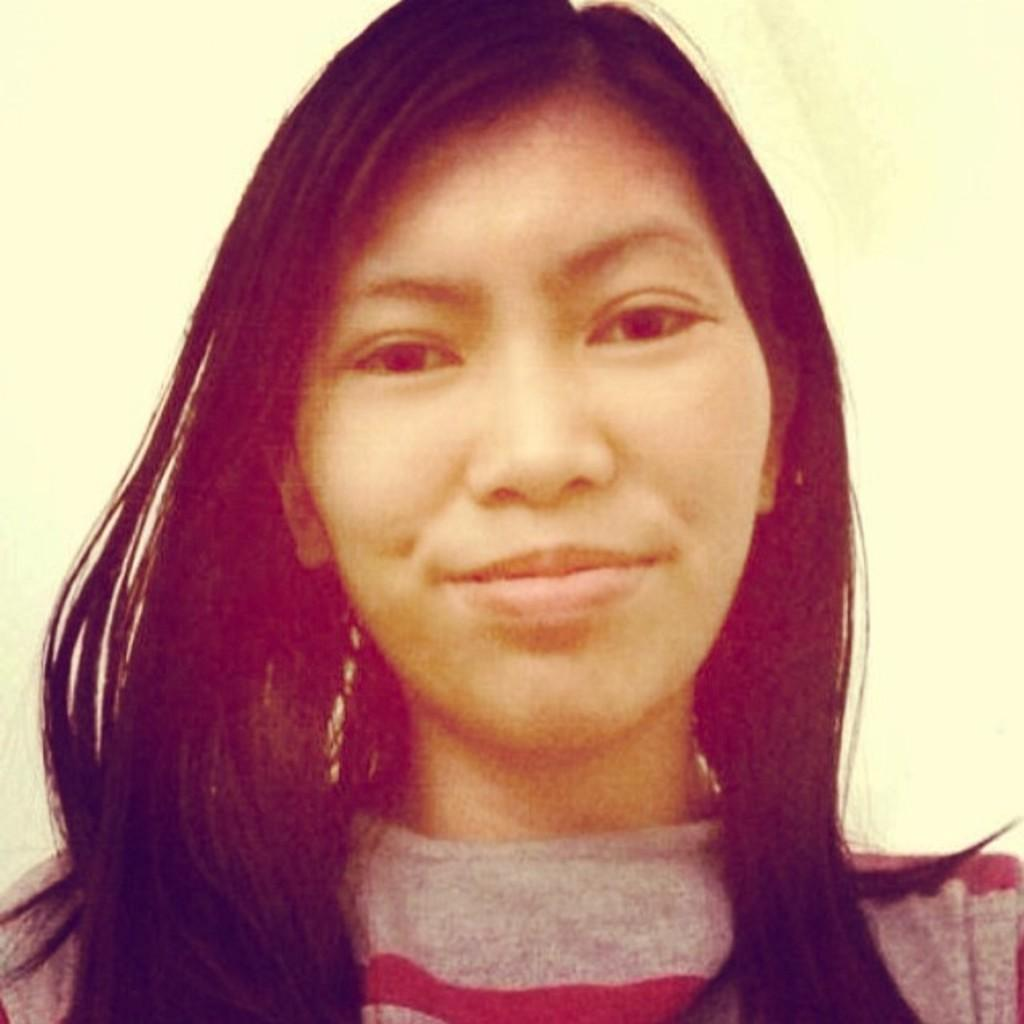Who is present in the image? There is a woman in the image. What is the woman's facial expression? The woman is smiling. What color is the background of the image? The background of the image is cream-colored. What type of key is the woman holding in the image? There is no key present in the image; it only features a woman with a smiling expression against a cream-colored background. 